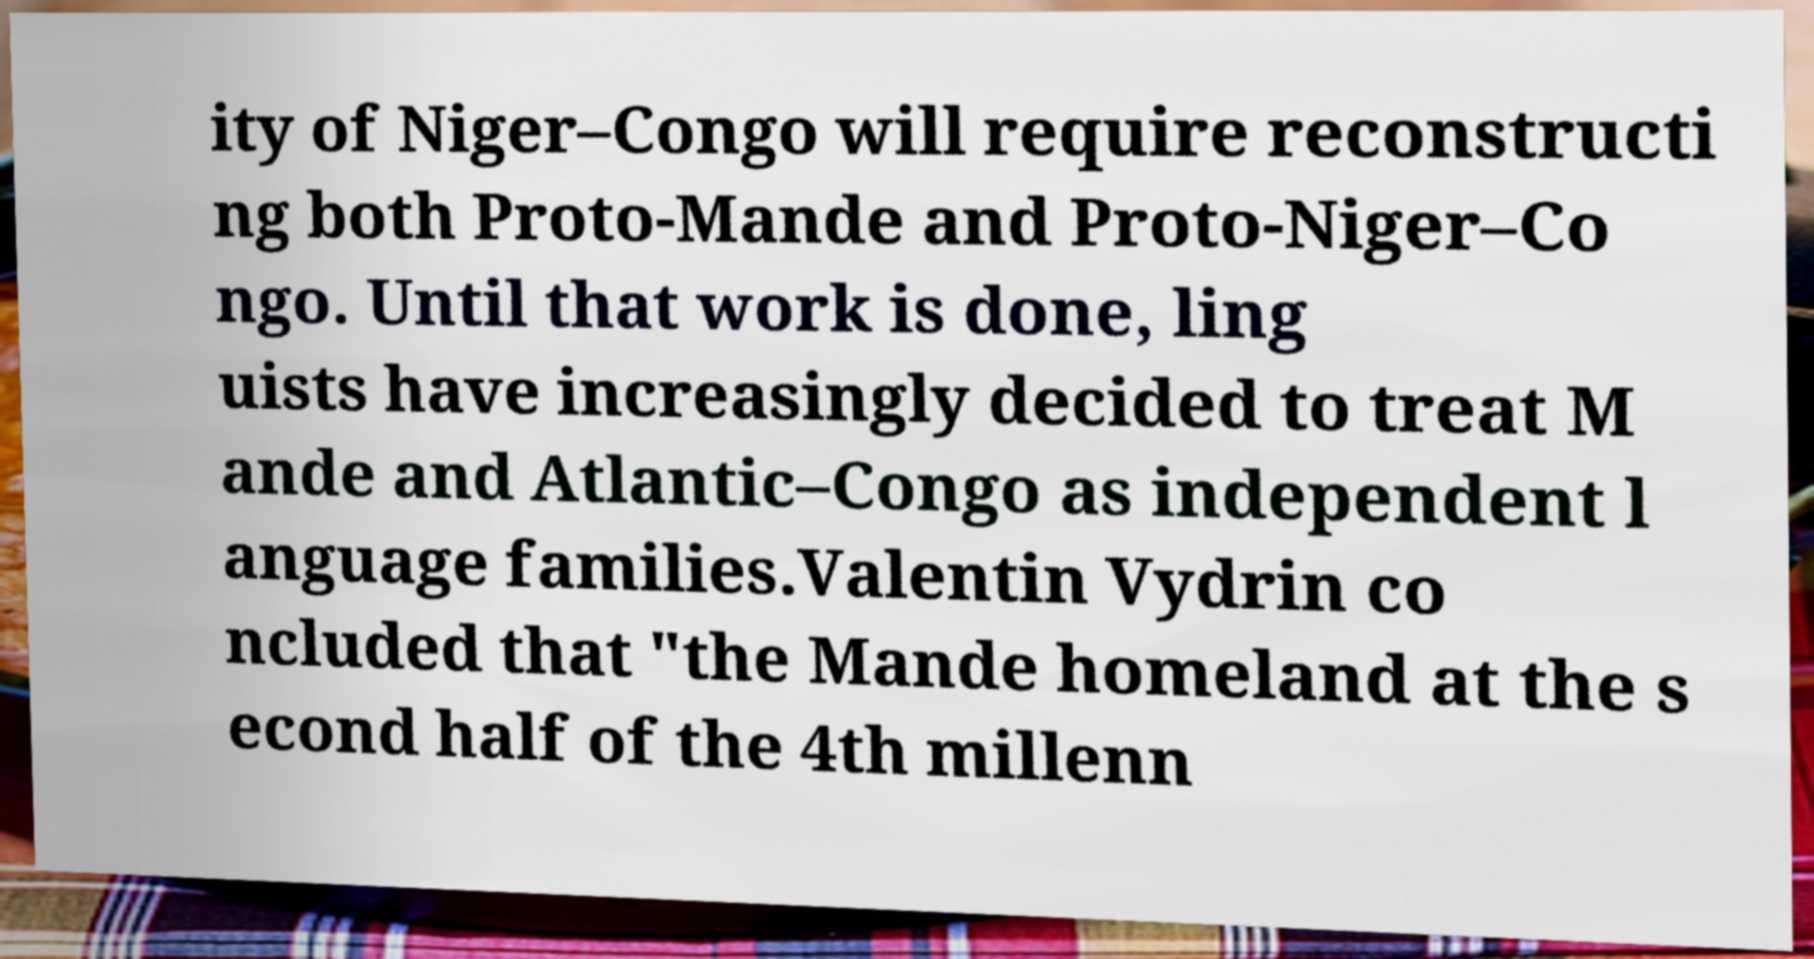Could you assist in decoding the text presented in this image and type it out clearly? ity of Niger–Congo will require reconstructi ng both Proto-Mande and Proto-Niger–Co ngo. Until that work is done, ling uists have increasingly decided to treat M ande and Atlantic–Congo as independent l anguage families.Valentin Vydrin co ncluded that "the Mande homeland at the s econd half of the 4th millenn 